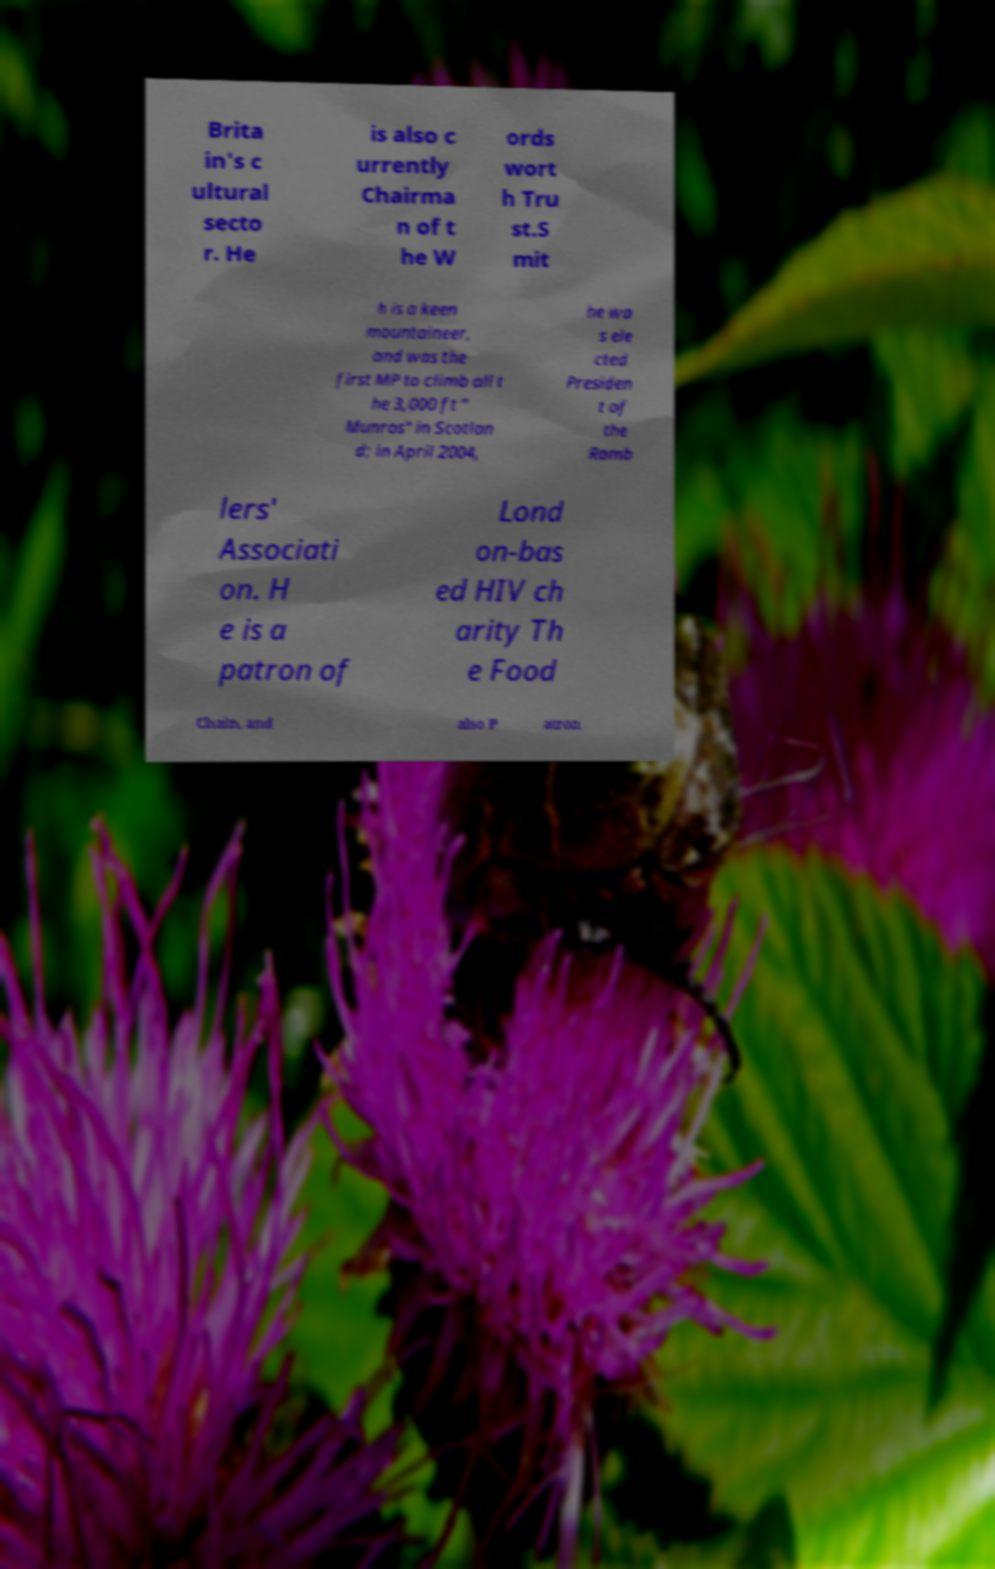For documentation purposes, I need the text within this image transcribed. Could you provide that? Brita in's c ultural secto r. He is also c urrently Chairma n of t he W ords wort h Tru st.S mit h is a keen mountaineer, and was the first MP to climb all t he 3,000 ft " Munros" in Scotlan d; in April 2004, he wa s ele cted Presiden t of the Ramb lers' Associati on. H e is a patron of Lond on-bas ed HIV ch arity Th e Food Chain, and also P atron 